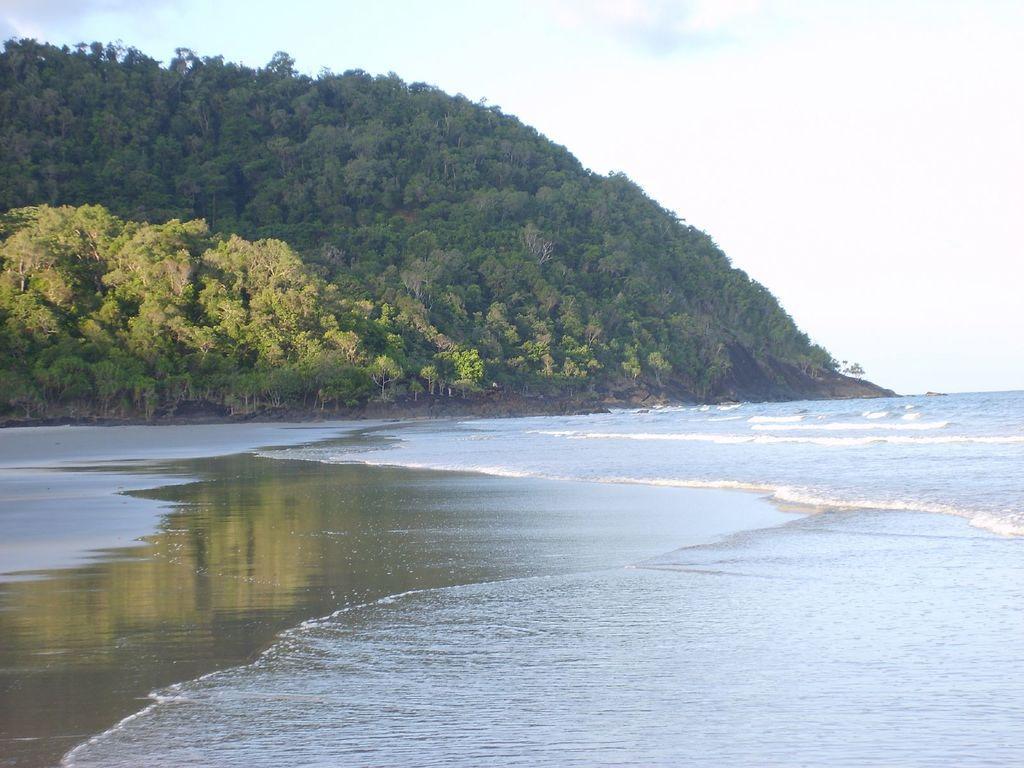Please provide a concise description of this image. It seems like a river in which there is water at the bottom. In the background there is a hill on which there are so many trees. At the top there is the sky. 